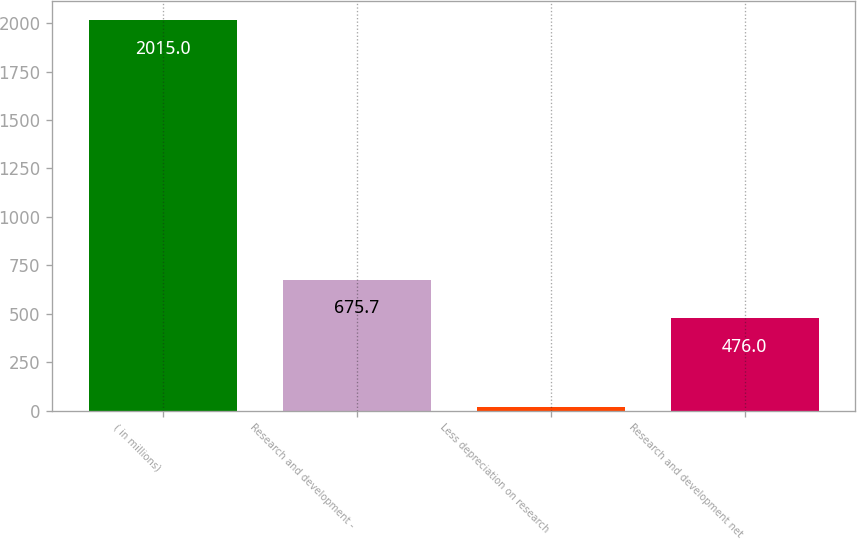Convert chart. <chart><loc_0><loc_0><loc_500><loc_500><bar_chart><fcel>( in millions)<fcel>Research and development -<fcel>Less depreciation on research<fcel>Research and development net<nl><fcel>2015<fcel>675.7<fcel>18<fcel>476<nl></chart> 